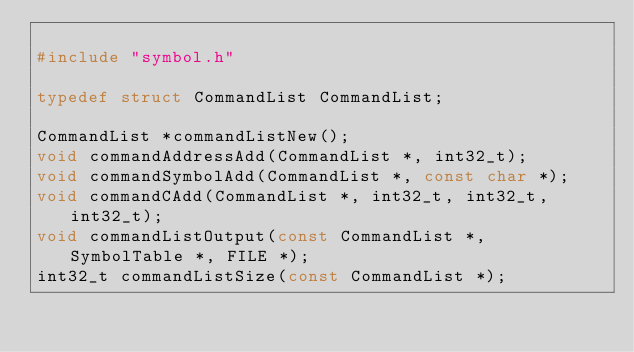Convert code to text. <code><loc_0><loc_0><loc_500><loc_500><_C_>
#include "symbol.h"

typedef struct CommandList CommandList;

CommandList *commandListNew();
void commandAddressAdd(CommandList *, int32_t);
void commandSymbolAdd(CommandList *, const char *);
void commandCAdd(CommandList *, int32_t, int32_t, int32_t);
void commandListOutput(const CommandList *, SymbolTable *, FILE *);
int32_t commandListSize(const CommandList *);
</code> 